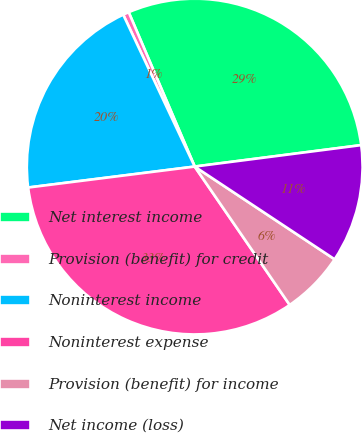Convert chart to OTSL. <chart><loc_0><loc_0><loc_500><loc_500><pie_chart><fcel>Net interest income<fcel>Provision (benefit) for credit<fcel>Noninterest income<fcel>Noninterest expense<fcel>Provision (benefit) for income<fcel>Net income (loss)<nl><fcel>29.39%<fcel>0.57%<fcel>19.99%<fcel>32.58%<fcel>6.11%<fcel>11.35%<nl></chart> 